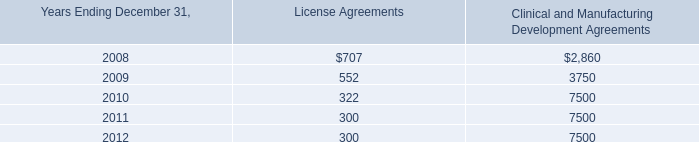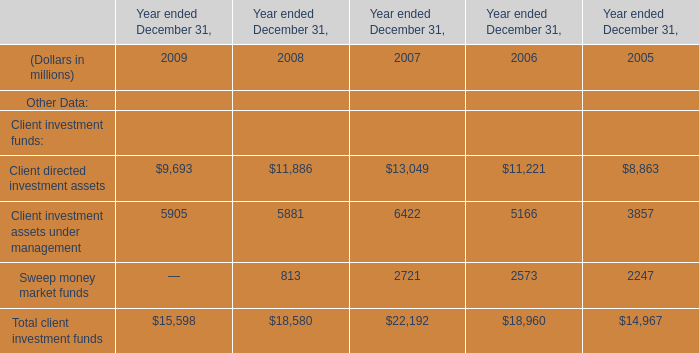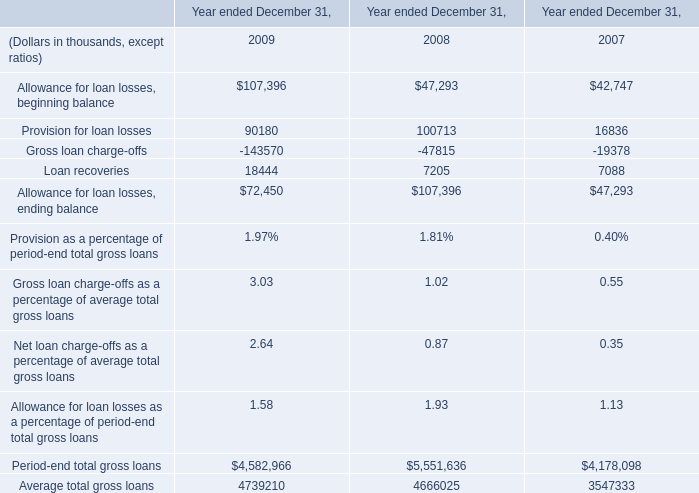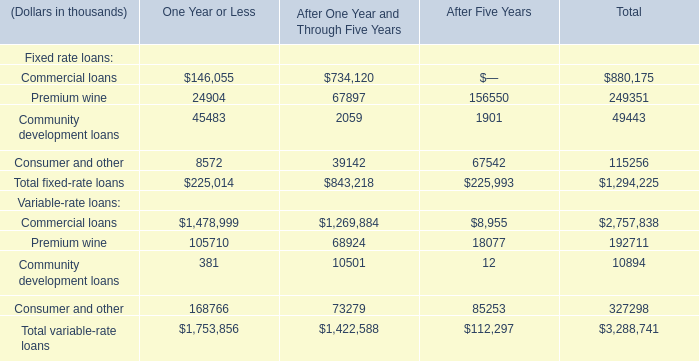As As the chart 3 shows,what is the Total fixed-rate loans for After One Year and Through Five Years? (in thousand) 
Answer: 843218. 